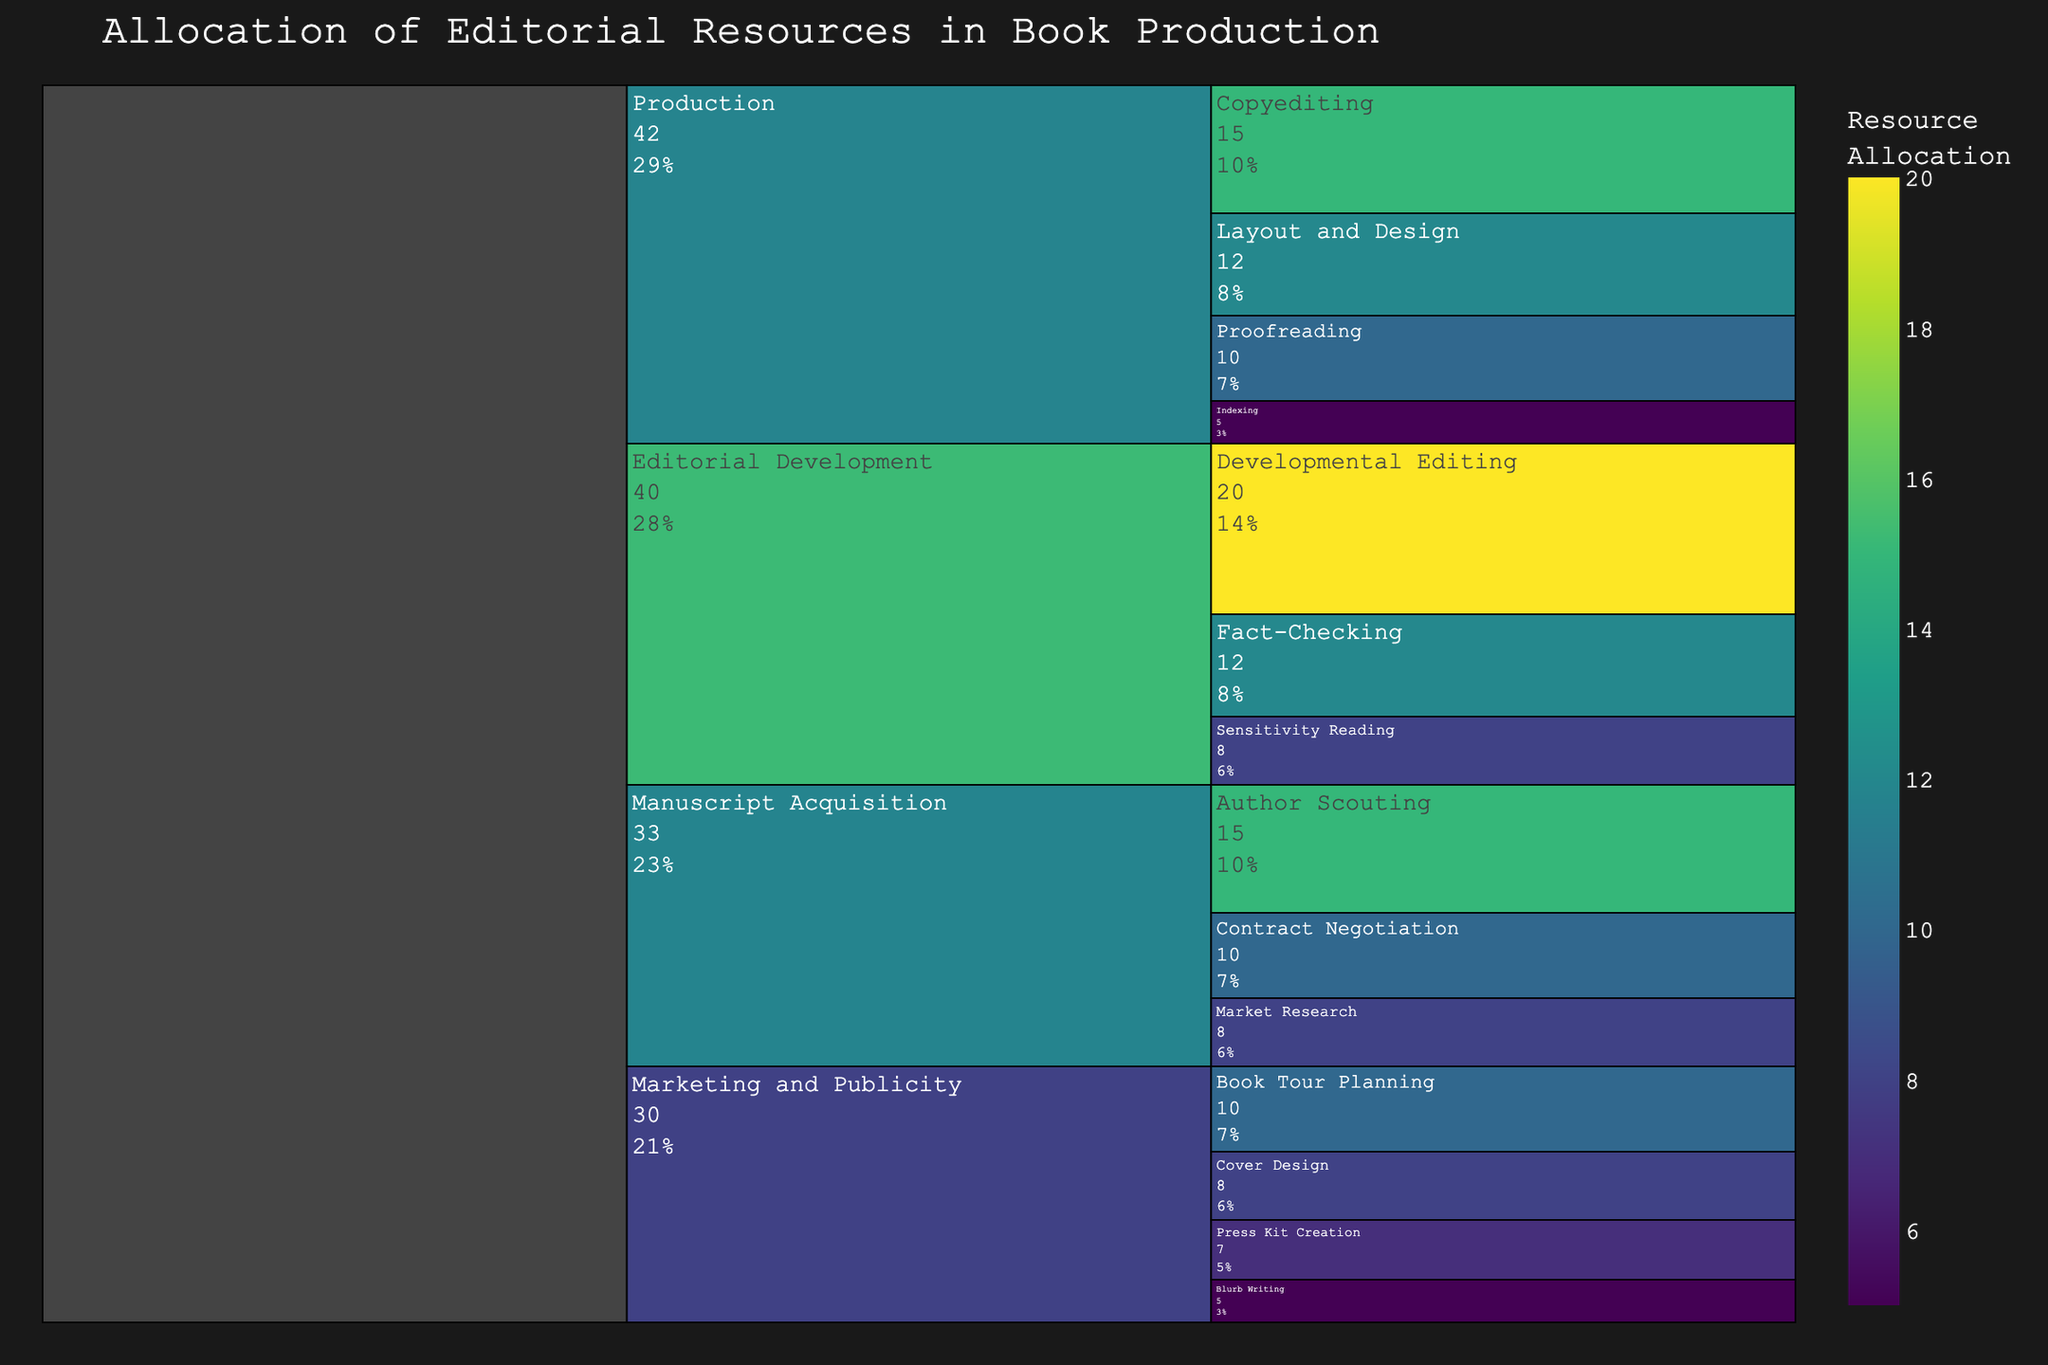What is the total resource allocation for the "Manuscript Acquisition" stage? From the figure, add the resource allocation values for all sub-stages under "Manuscript Acquisition" which are Author Scouting (15), Contract Negotiation (10), and Market Research (8). So, 15 + 10 + 8 = 33.
Answer: 33 Which sub-stage within "Editorial Development" has the highest resource allocation? The sub-stages under "Editorial Development" are Developmental Editing (20), Fact-Checking (12), and Sensitivity Reading (8). Among these, Developmental Editing has the highest resource allocation of 20.
Answer: Developmental Editing How does the resource allocation for "Copyediting" compare to "Proofreading"? The resource allocation for "Copyediting" is 15 and for "Proofreading" is 10. Comparing these values, Copyediting has a higher resource allocation.
Answer: Copyediting What percentage of total resources is allocated for "Production"? To find this, sum the resource allocations within the "Production" stage: Copyediting (15), Proofreading (10), Layout and Design (12), and Indexing (5). So the total is 15 + 10 + 12 + 5 = 42. To find the percentage: (42 / 120) * 100 = 35%.
Answer: 35% What is the difference in resource allocation between "Developmental Editing" and "Author Scouting"? The allocation for "Developmental Editing" is 20 and for "Author Scouting" is 15. Subtract the latter from the former: 20 - 15 = 5.
Answer: 5 Which stage has the least resource allocation? By summing sub-stage values, "Marketing and Publicity" has allocations: Cover Design (8), Blurb Writing (5), Press Kit Creation (7), and Book Tour Planning (10). Total is 30, which is lower compared to other stages - Manuscript Acquisition (33), Editorial Development (40), Production (42). So, Marketing and Publicity has the least allocation.
Answer: Marketing and Publicity How is the resource allocation for "Sensitivity Reading" visually represented in terms of color? By observing the color scale in the chart, "Sensitivity Reading" with an allocation of 8 should be represented with a color closer to the lower end of the scale, indicating a lighter shade within the "Viridis" color spectrum.
Answer: Light shade What combined percentage of resources is allocated to "Fact-Checking" and "Sensitivity Reading"? First, sum the individual allocations: Fact-Checking (12) and Sensitivity Reading (8), for a total of 12 + 8 = 20. Calculate the percentage: (20 / 120) * 100 = 16.7%.
Answer: 16.7% How many sub-stages are shown under the "Marketing and Publicity" stage? From the chart, we can see the sub-stages are Cover Design, Blurb Writing, Press Kit Creation, and Book Tour Planning. This makes a total of 4 sub-stages.
Answer: 4 